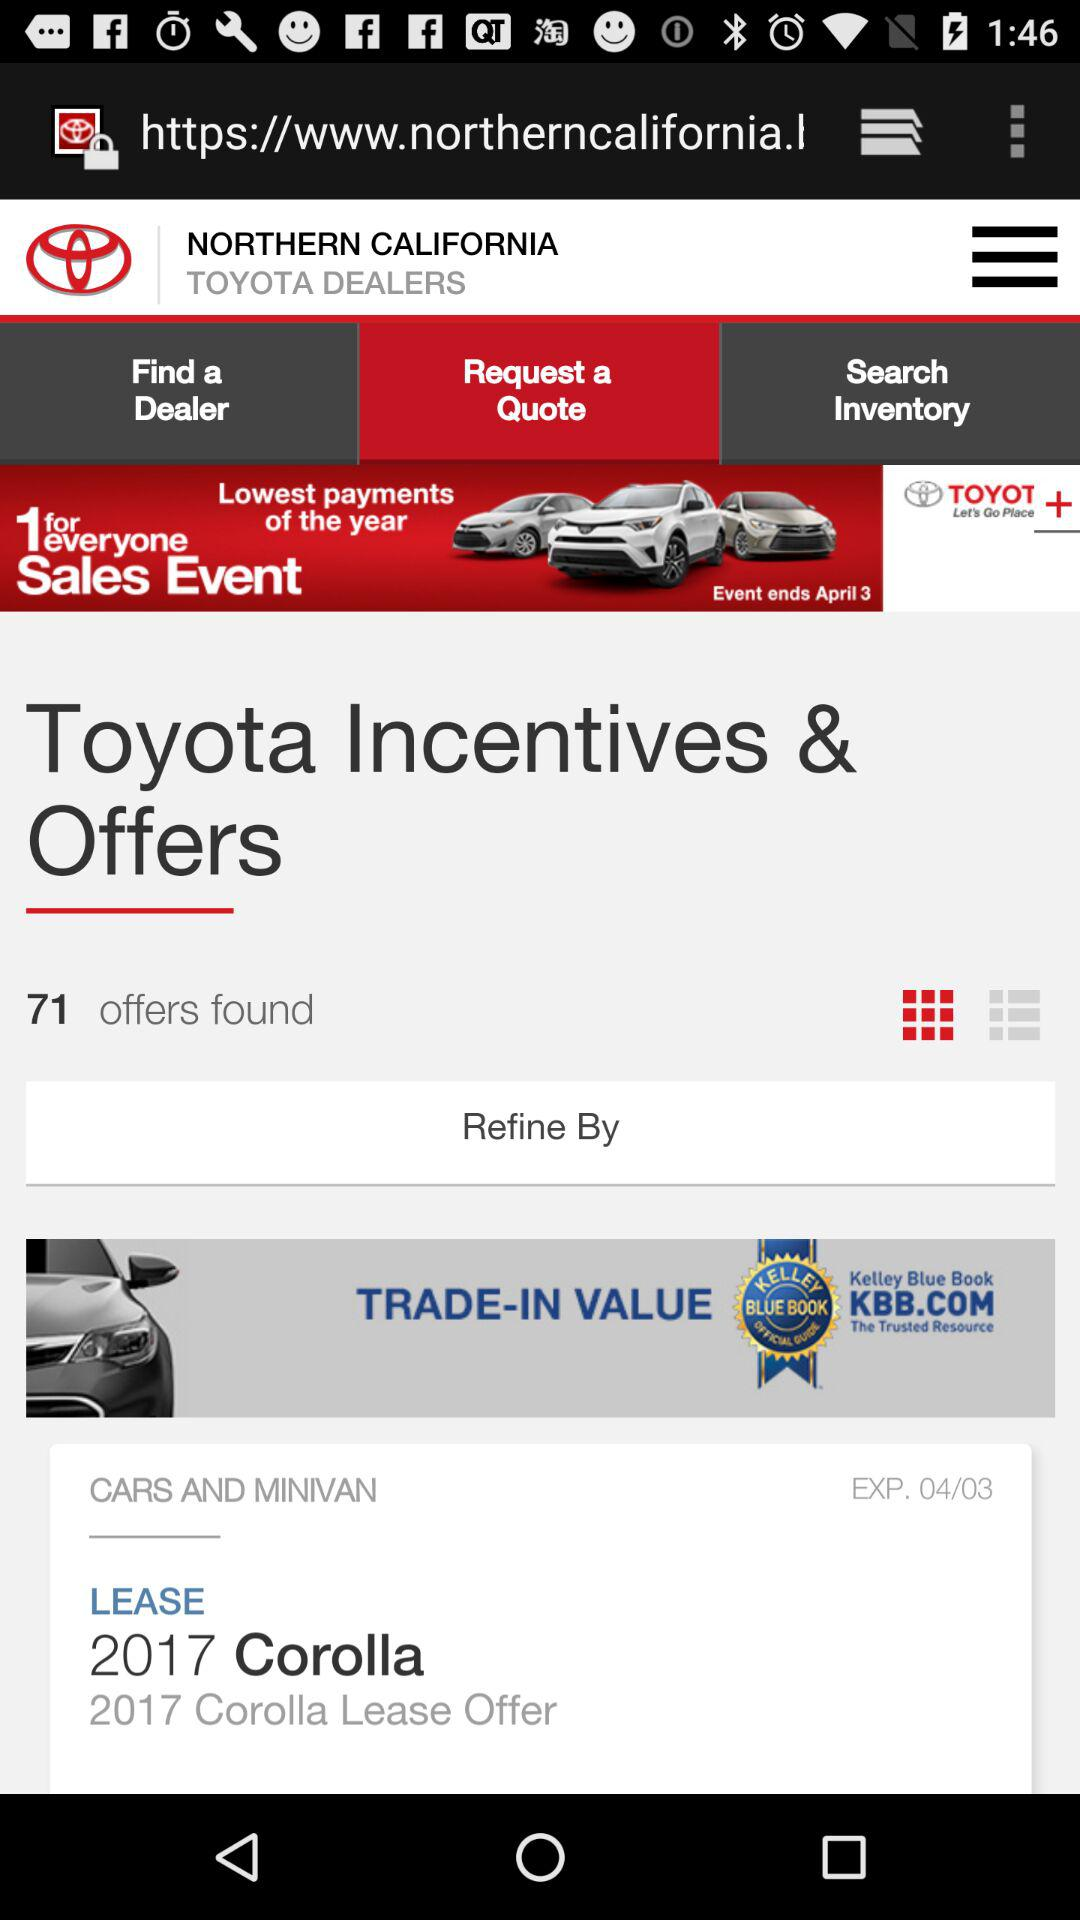Which tab has been selected? The selected tab is "Request a Quote". 